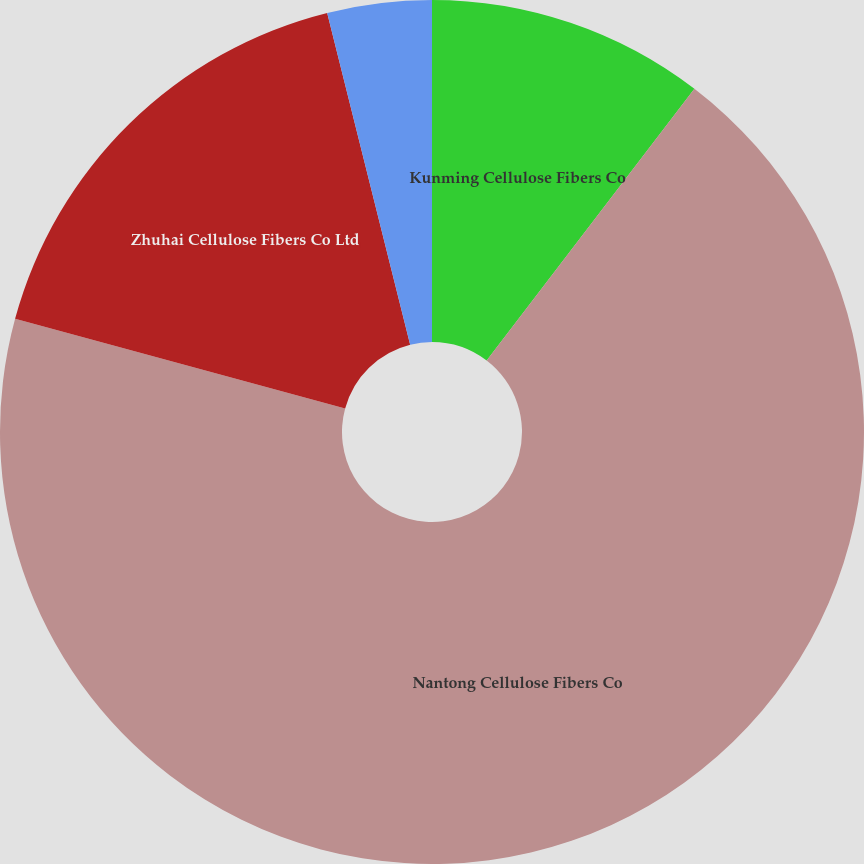<chart> <loc_0><loc_0><loc_500><loc_500><pie_chart><fcel>Kunming Cellulose Fibers Co<fcel>Nantong Cellulose Fibers Co<fcel>Zhuhai Cellulose Fibers Co Ltd<fcel>InfraServ GmbH & Co Wiesbaden<nl><fcel>10.39%<fcel>68.83%<fcel>16.88%<fcel>3.9%<nl></chart> 